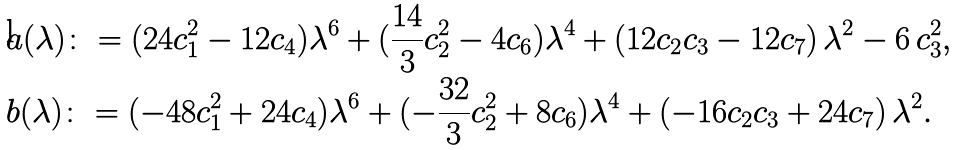<formula> <loc_0><loc_0><loc_500><loc_500>& a ( \lambda ) \colon = ( 2 4 c _ { 1 } ^ { 2 } - 1 2 c _ { 4 } ) \lambda ^ { 6 } + ( \frac { 1 4 } { 3 } c _ { 2 } ^ { 2 } - 4 c _ { 6 } ) \lambda ^ { 4 } + ( 1 2 c _ { 2 } c _ { 3 } - 1 2 c _ { 7 } ) \, \lambda ^ { 2 } - 6 \, c _ { 3 } ^ { 2 } , \\ & b ( \lambda ) \colon = ( - 4 8 c _ { 1 } ^ { 2 } + 2 4 c _ { 4 } ) \lambda ^ { 6 } + ( - \frac { 3 2 } { 3 } c _ { 2 } ^ { 2 } + 8 c _ { 6 } ) \lambda ^ { 4 } + ( - 1 6 c _ { 2 } c _ { 3 } + 2 4 c _ { 7 } ) \, \lambda ^ { 2 } .</formula> 